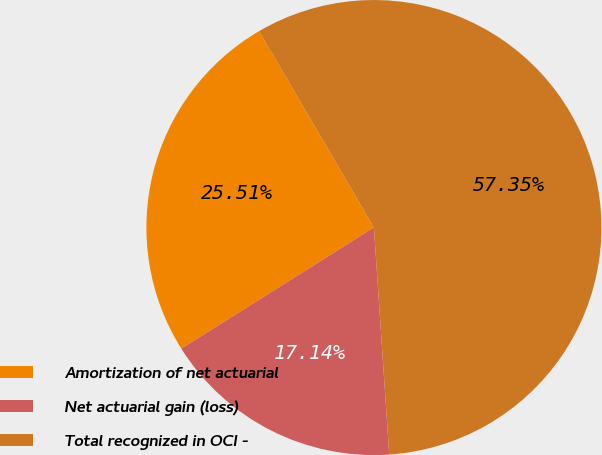Convert chart to OTSL. <chart><loc_0><loc_0><loc_500><loc_500><pie_chart><fcel>Amortization of net actuarial<fcel>Net actuarial gain (loss)<fcel>Total recognized in OCI -<nl><fcel>25.51%<fcel>17.14%<fcel>57.35%<nl></chart> 